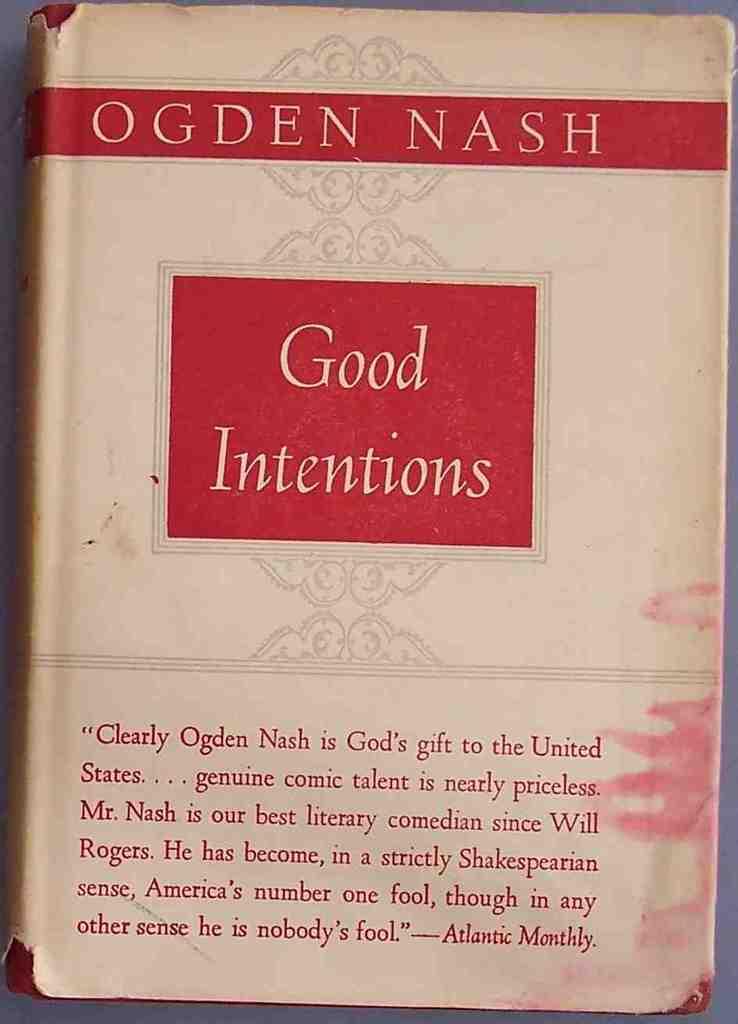Is this good intentions?
Make the answer very short. Yes. Who is the author of good intentions?
Your answer should be compact. Ogden nash. 